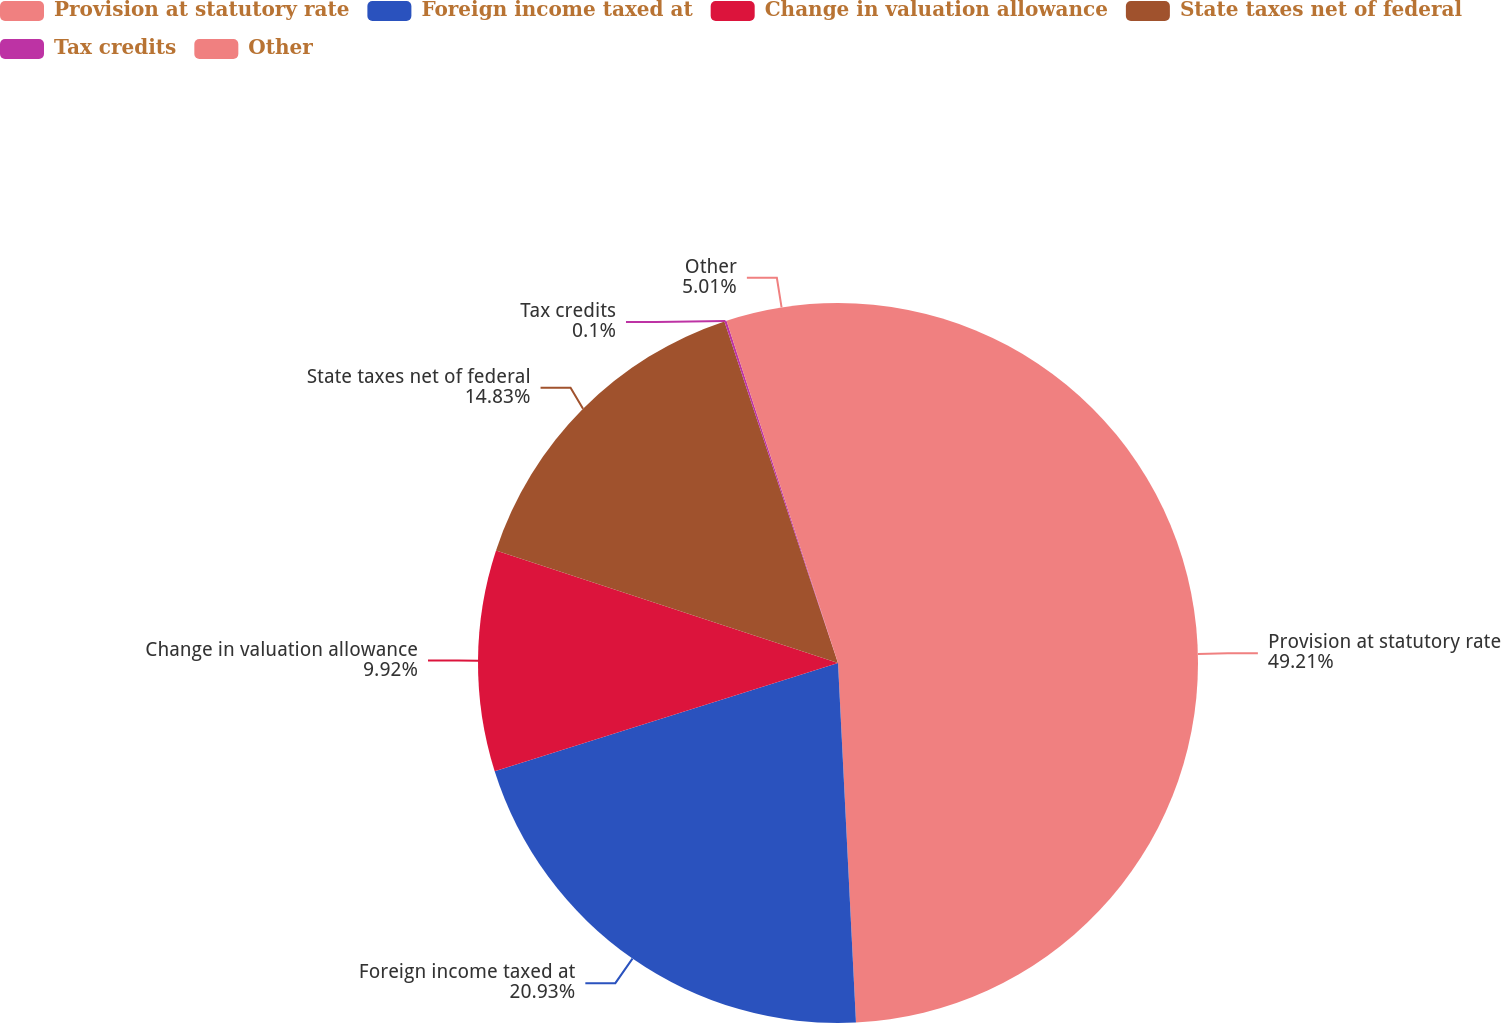Convert chart to OTSL. <chart><loc_0><loc_0><loc_500><loc_500><pie_chart><fcel>Provision at statutory rate<fcel>Foreign income taxed at<fcel>Change in valuation allowance<fcel>State taxes net of federal<fcel>Tax credits<fcel>Other<nl><fcel>49.2%<fcel>20.93%<fcel>9.92%<fcel>14.83%<fcel>0.1%<fcel>5.01%<nl></chart> 